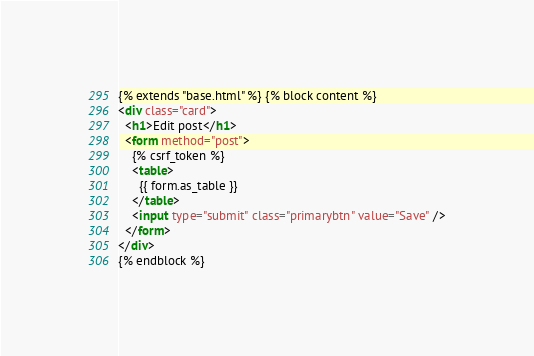<code> <loc_0><loc_0><loc_500><loc_500><_HTML_>{% extends "base.html" %} {% block content %}
<div class="card">
  <h1>Edit post</h1>
  <form method="post">
    {% csrf_token %}
    <table>
      {{ form.as_table }}
    </table>
    <input type="submit" class="primarybtn" value="Save" />
  </form>
</div>
{% endblock %}
</code> 